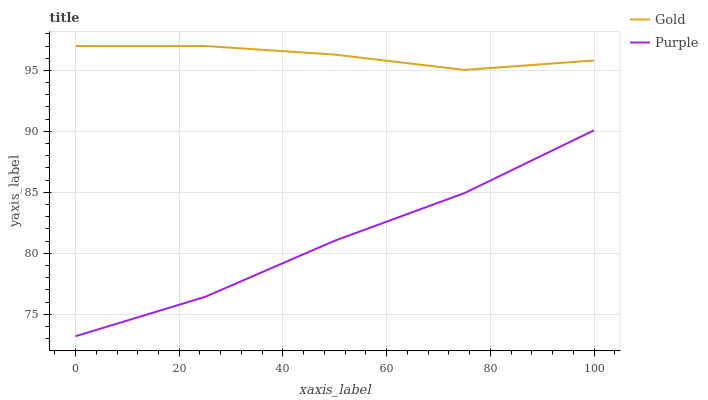Does Purple have the minimum area under the curve?
Answer yes or no. Yes. Does Gold have the maximum area under the curve?
Answer yes or no. Yes. Does Gold have the minimum area under the curve?
Answer yes or no. No. Is Gold the smoothest?
Answer yes or no. Yes. Is Purple the roughest?
Answer yes or no. Yes. Is Gold the roughest?
Answer yes or no. No. Does Gold have the lowest value?
Answer yes or no. No. Does Gold have the highest value?
Answer yes or no. Yes. Is Purple less than Gold?
Answer yes or no. Yes. Is Gold greater than Purple?
Answer yes or no. Yes. Does Purple intersect Gold?
Answer yes or no. No. 